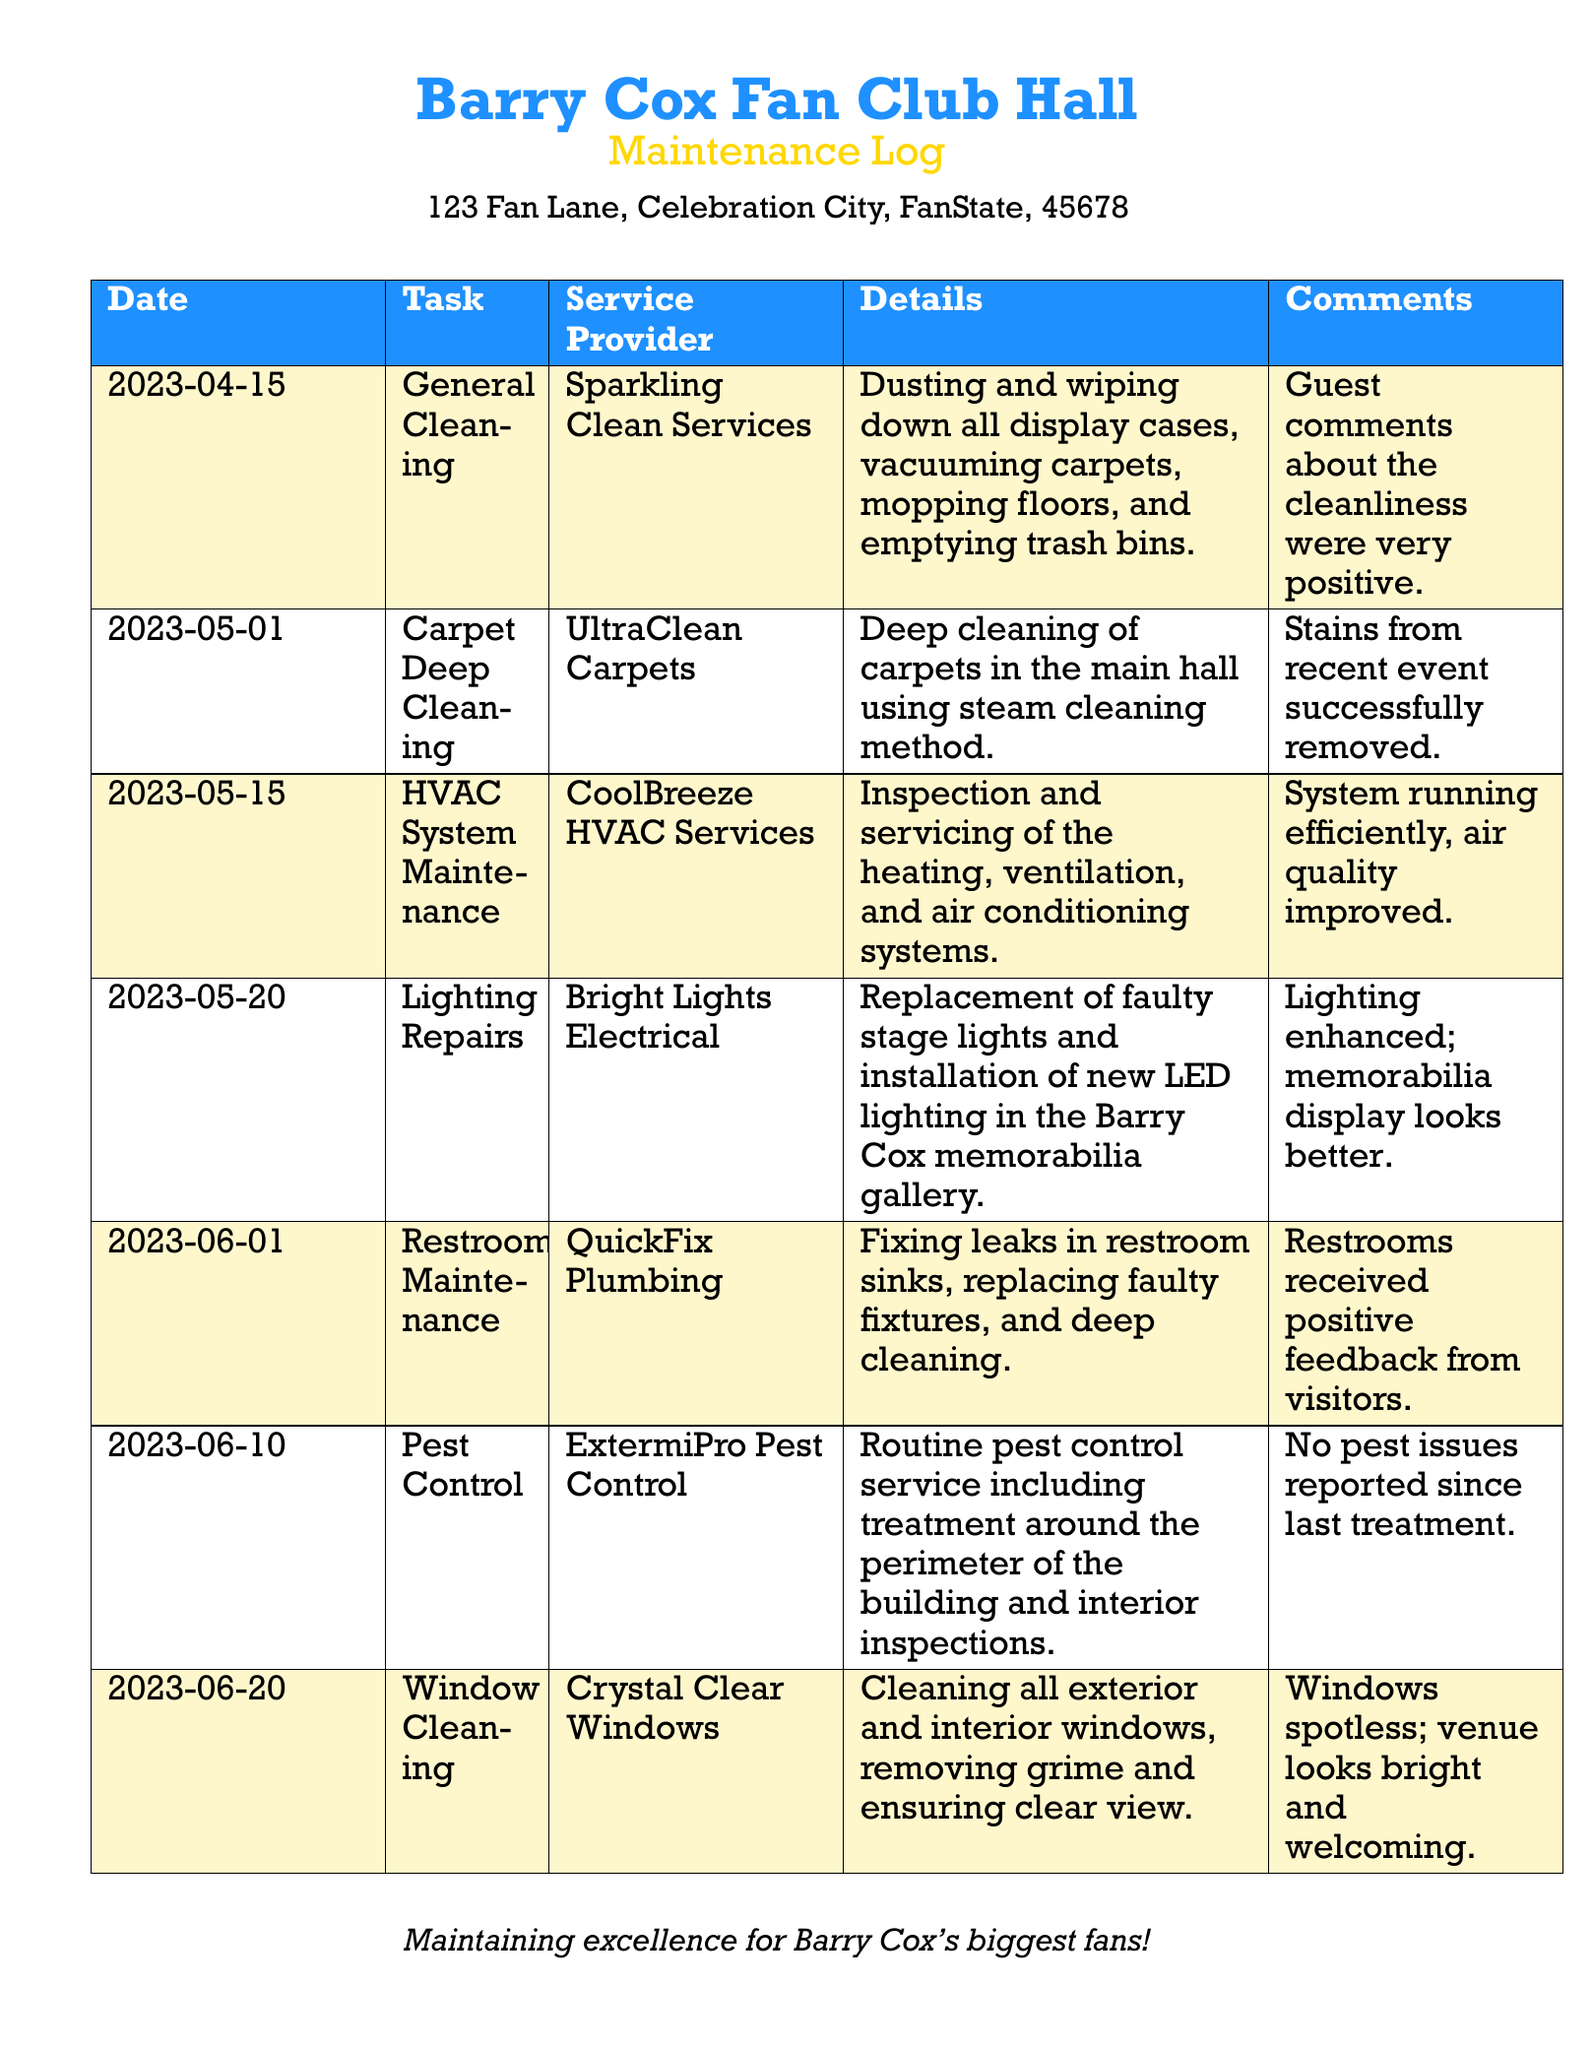what date was the general cleaning conducted? The date for the general cleaning task is listed as 2023-04-15.
Answer: 2023-04-15 who provided the carpet deep cleaning service? The service provider for the carpet deep cleaning was UltraClean Carpets.
Answer: UltraClean Carpets how many tasks are mentioned in the maintenance log? The maintenance log includes a total of six tasks listed under the 'Task' column.
Answer: 6 when was the last pest control service carried out? The last pest control service was done on 2023-06-10.
Answer: 2023-06-10 what type of maintenance was performed on June 1st? The maintenance performed on June 1st was restroom maintenance.
Answer: Restroom Maintenance which service provider handled the HVAC system maintenance? The HVAC system maintenance was handled by CoolBreeze HVAC Services.
Answer: CoolBreeze HVAC Services what was the comment about the restroom feedback? The comment regarding the restroom feedback was that they received positive feedback from visitors.
Answer: Positive feedback from visitors which repair involved the Barry Cox memorabilia gallery? The lighting repairs involved installing new LED lighting in the Barry Cox memorabilia gallery.
Answer: LED lighting in the memorabilia gallery 